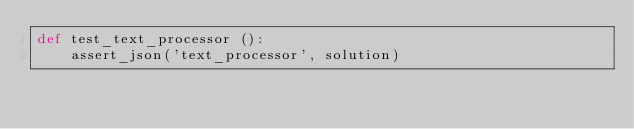<code> <loc_0><loc_0><loc_500><loc_500><_Python_>def test_text_processor ():
    assert_json('text_processor', solution)
</code> 